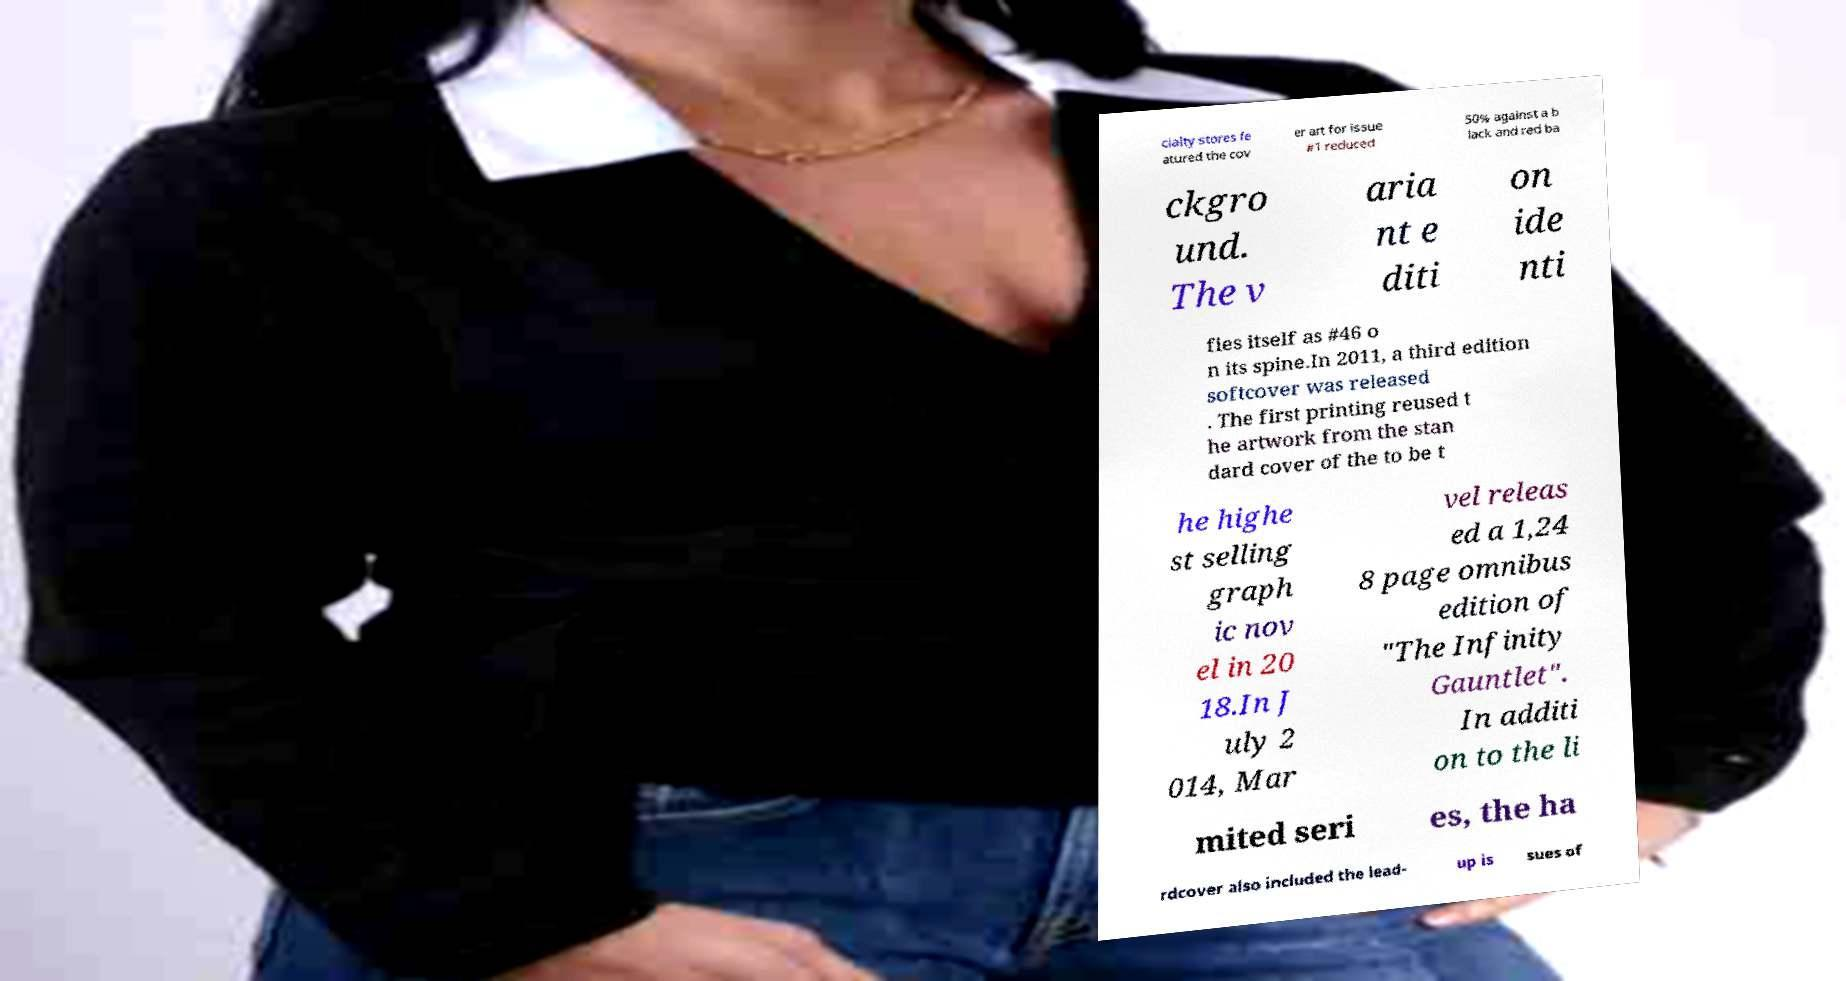I need the written content from this picture converted into text. Can you do that? cialty stores fe atured the cov er art for issue #1 reduced 50% against a b lack and red ba ckgro und. The v aria nt e diti on ide nti fies itself as #46 o n its spine.In 2011, a third edition softcover was released . The first printing reused t he artwork from the stan dard cover of the to be t he highe st selling graph ic nov el in 20 18.In J uly 2 014, Mar vel releas ed a 1,24 8 page omnibus edition of "The Infinity Gauntlet". In additi on to the li mited seri es, the ha rdcover also included the lead- up is sues of 